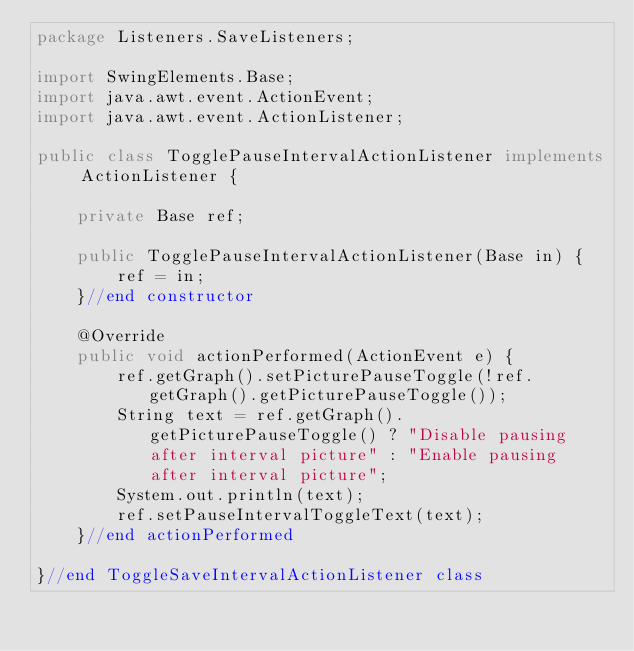<code> <loc_0><loc_0><loc_500><loc_500><_Java_>package Listeners.SaveListeners;

import SwingElements.Base;
import java.awt.event.ActionEvent;
import java.awt.event.ActionListener;

public class TogglePauseIntervalActionListener implements ActionListener {

    private Base ref;

    public TogglePauseIntervalActionListener(Base in) {
        ref = in;
    }//end constructor

    @Override
    public void actionPerformed(ActionEvent e) {
        ref.getGraph().setPicturePauseToggle(!ref.getGraph().getPicturePauseToggle());
        String text = ref.getGraph().getPicturePauseToggle() ? "Disable pausing after interval picture" : "Enable pausing after interval picture";
        System.out.println(text);
        ref.setPauseIntervalToggleText(text);
    }//end actionPerformed

}//end ToggleSaveIntervalActionListener class

</code> 